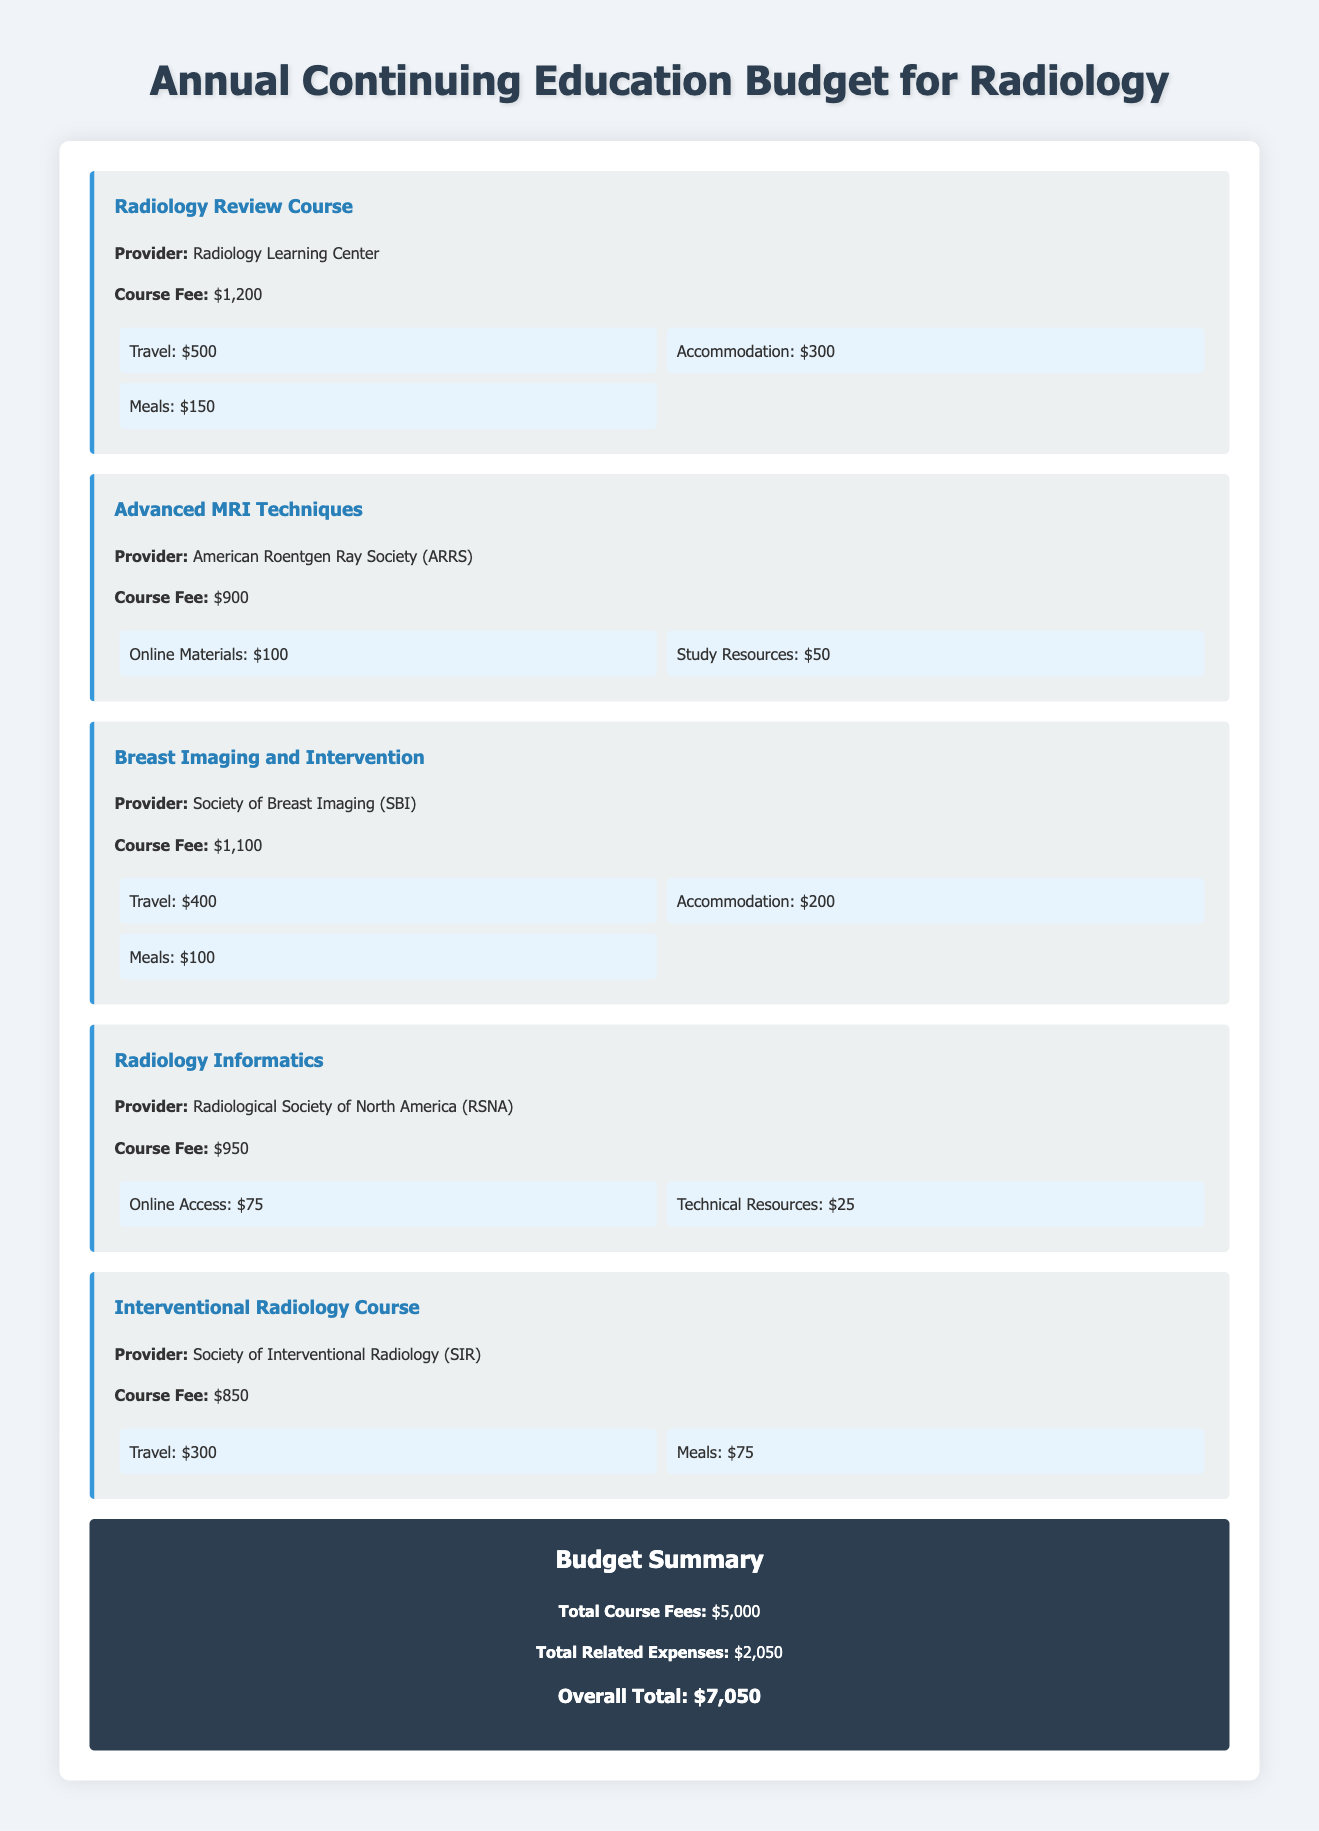What is the total course fee for all courses? The total course fee is presented in the summary section of the document and is the sum of all course fees listed.
Answer: $5,000 What is the provider for the "Advanced MRI Techniques" course? The provider's name is included in the details of that specific course in the document.
Answer: American Roentgen Ray Society (ARRS) How much is the travel expense for the "Radiology Review Course"? The travel expense is listed as part of the related expenses for that course in the document.
Answer: $500 What is the total amount allocated for related expenses? The total for related expenses is provided in the budget summary section, which is the sum of all related expenses across the courses.
Answer: $2,050 Which course has the highest course fee? This information is determined by comparing the course fees listed for each course in the document.
Answer: Radiology Review Course How much is the accommodation expense for the "Breast Imaging and Intervention" course? The accommodation expense is mentioned in the related expenses section for that course and specifies the amount.
Answer: $200 What is the overall total for the annual continuing education budget? The overall total is calculated by adding the total course fees and the total related expenses, as shown in the summary section.
Answer: $7,050 What course focuses on informatics? The document explicitly states the name of the course that focuses on this area in the title of the relevant section.
Answer: Radiology Informatics What expenses are listed under the "Interventional Radiology Course"? The expenses are detailed in the course section, which specifies what the related costs are.
Answer: Travel: $300, Meals: $75 